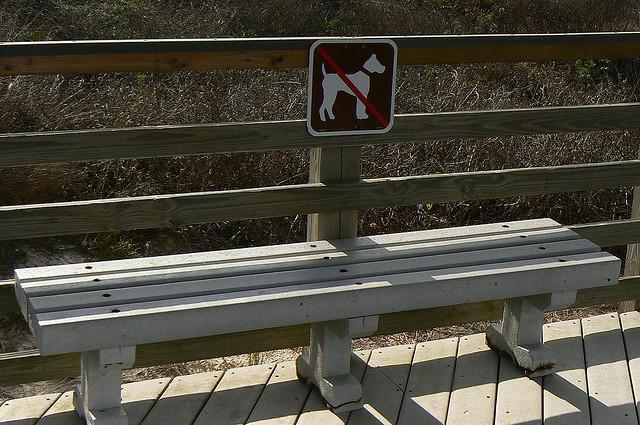How many glasses are full of orange juice?
Give a very brief answer. 0. 